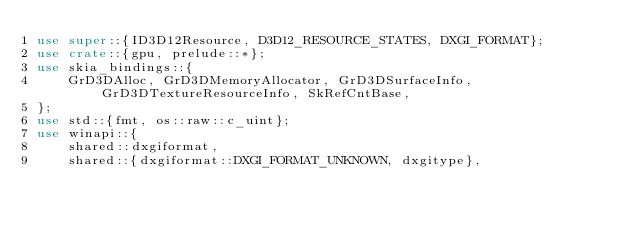Convert code to text. <code><loc_0><loc_0><loc_500><loc_500><_Rust_>use super::{ID3D12Resource, D3D12_RESOURCE_STATES, DXGI_FORMAT};
use crate::{gpu, prelude::*};
use skia_bindings::{
    GrD3DAlloc, GrD3DMemoryAllocator, GrD3DSurfaceInfo, GrD3DTextureResourceInfo, SkRefCntBase,
};
use std::{fmt, os::raw::c_uint};
use winapi::{
    shared::dxgiformat,
    shared::{dxgiformat::DXGI_FORMAT_UNKNOWN, dxgitype},</code> 